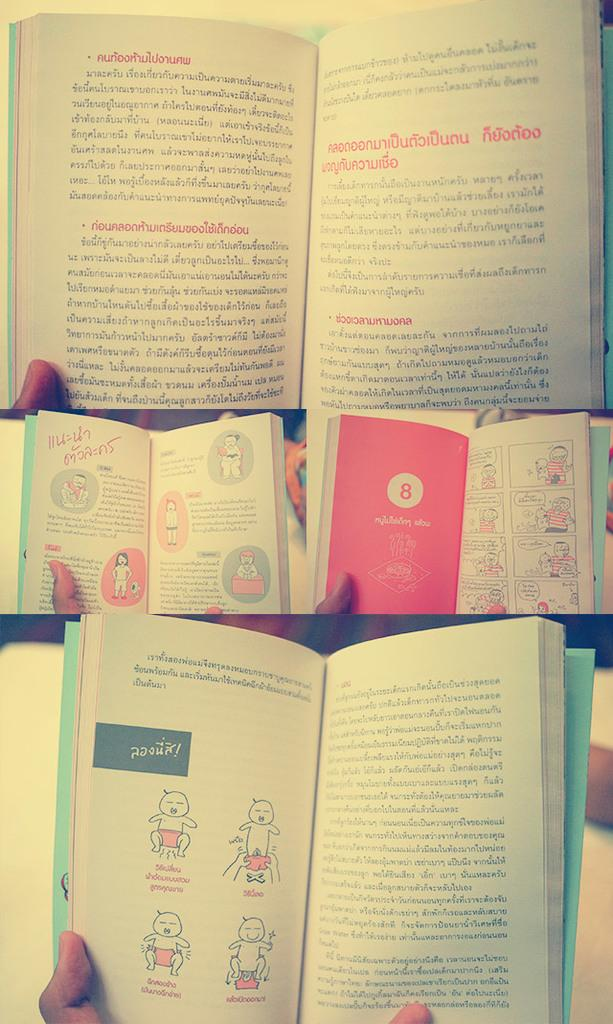Provide a one-sentence caption for the provided image. A book with a cartoon drawing of a man and a baby has a red page with a number 8 on it. 